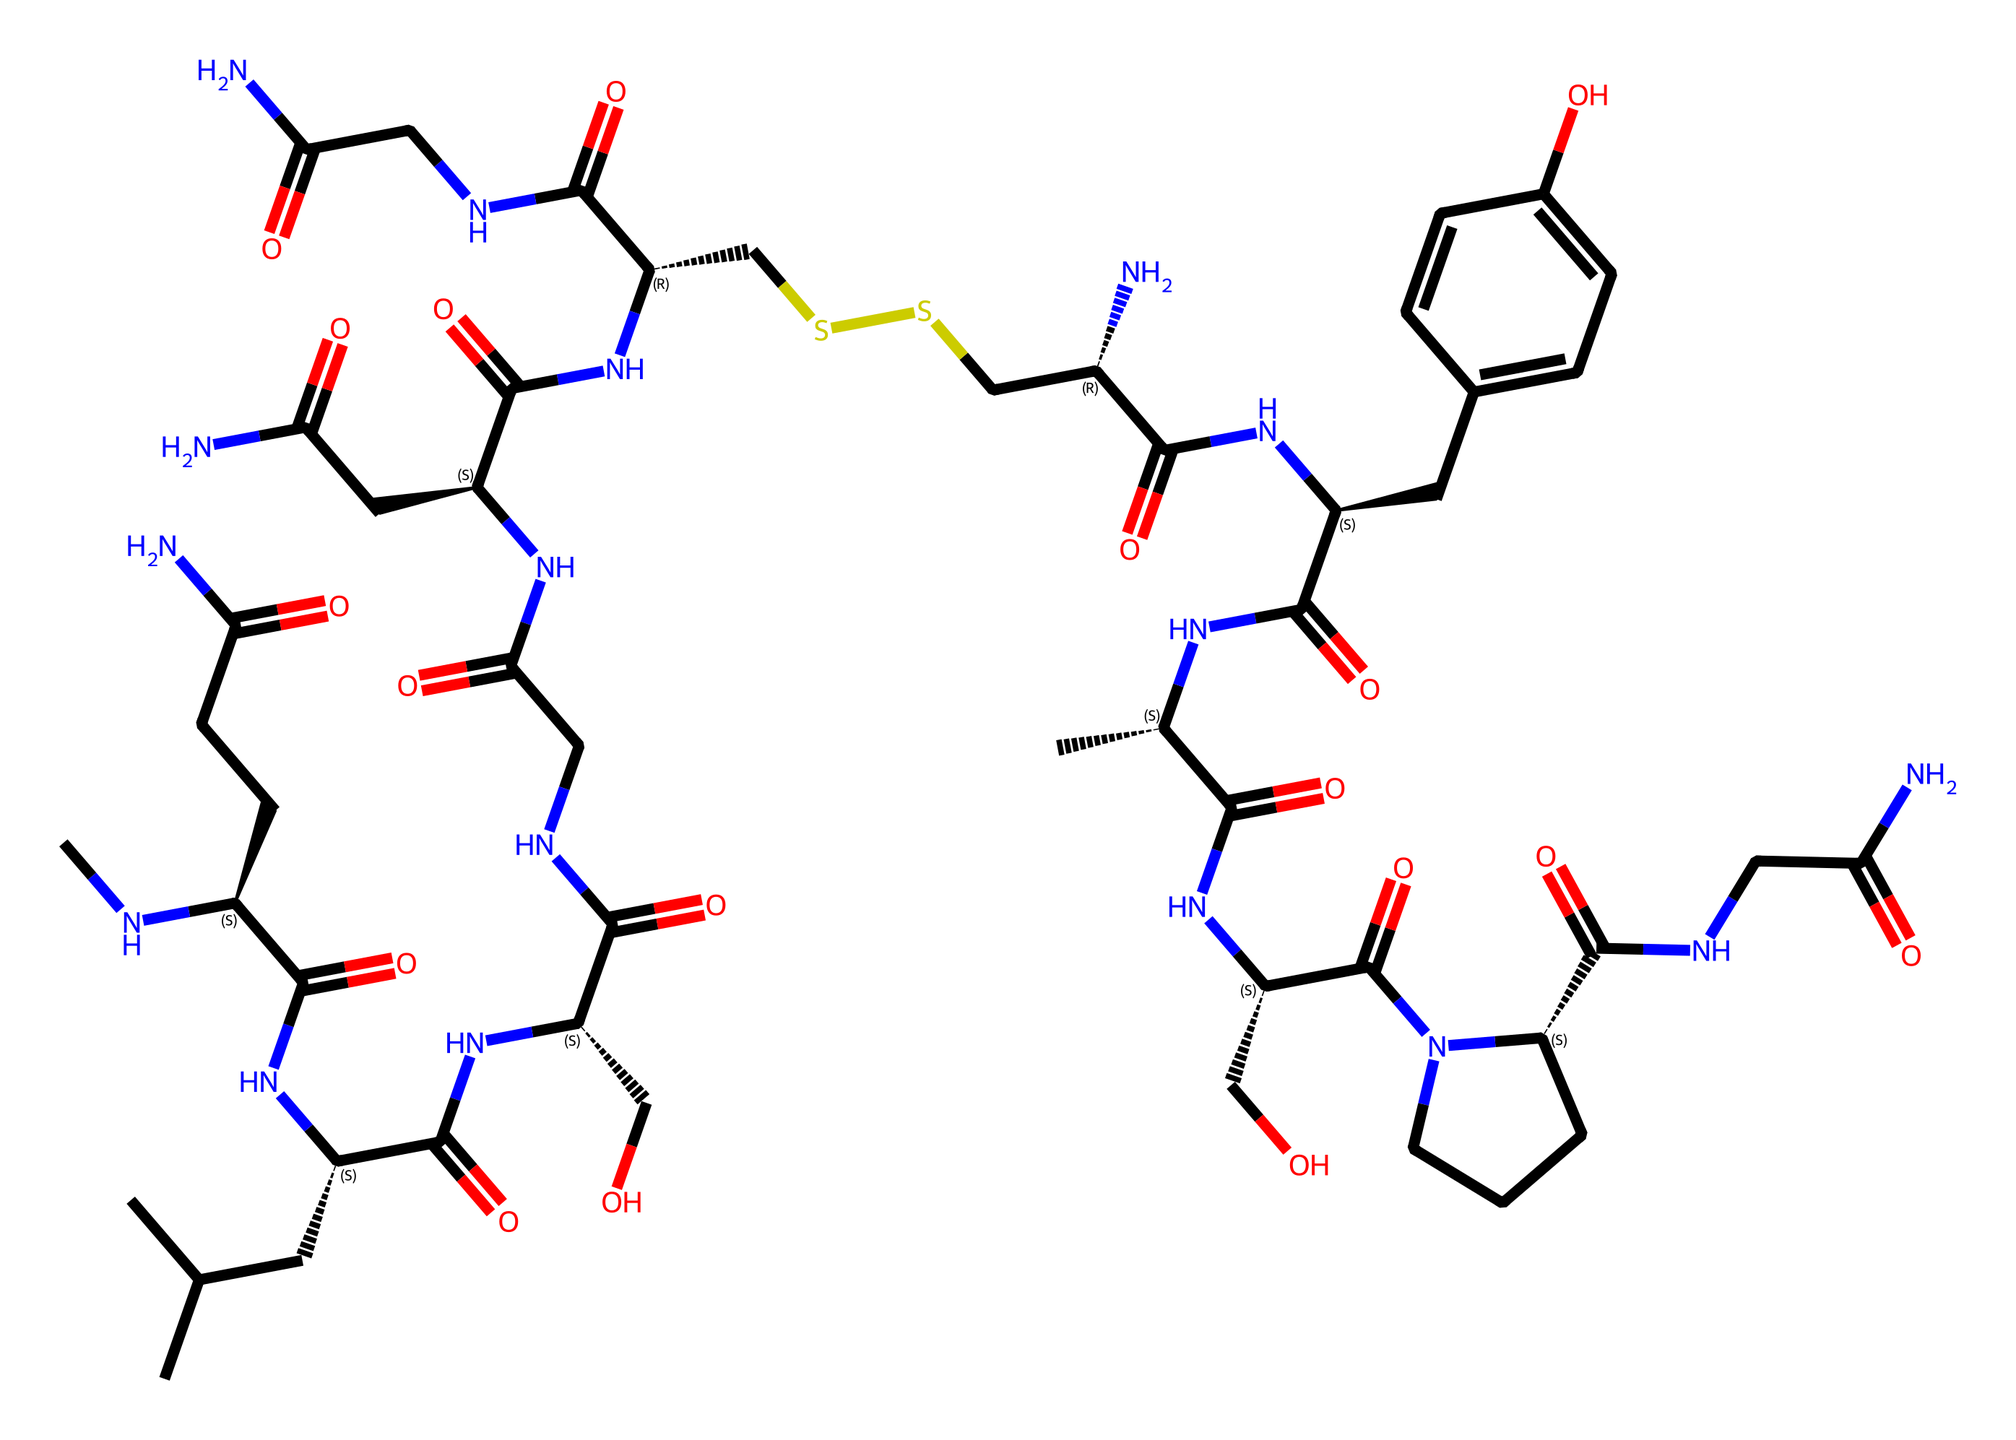What is the molecular formula for this chemical? To determine the molecular formula, count the number of each type of atom present in the SMILES representation. Identify the carbon (C), hydrogen (H), nitrogen (N), oxygen (O), and sulfur (S) atoms and sum them up to form the formula. The counts yield C43, H66, N12, O10, S2.
Answer: C43H66N12O10S2 How many nitrogen atoms are present in the structure? Review the SMILES string for nitrogen (N) atoms. By counting the occurrences, there are 12 nitrogen atoms in the chemical's structure.
Answer: 12 What type of bonding is predominant in this chemical? Looking at the SMILES representation, this compound contains multiple amide groups (indicated by the NC=O bonds), which means that covalent bonds are predominant due to the connections among carbon, nitrogen, and oxygen.
Answer: covalent Which functional groups are present in this chemical? Analyze the structure for common functional groups. The SMILES indicates the presence of amides (RCONH), hydroxyl groups (–OH), and disulfide linkages (–S–S–). Identifying these groups gives insight into the overall chemical behavior.
Answer: amides, hydroxyls, disulfide What does the presence of sulfur indicate about this chemical's properties? The presence of sulfur in the disulfide groups is crucial for protein structure and function, indicating that this chemical may play a role in protein interactions and stability due to the formation of disulfide bridges.
Answer: protein interactions How many chiral centers are in this molecule? Examine the SMILES to find the chirality centers, which are generally marked by the symbols @ or @@. Counting these gives the total number of chiral centers. There are 6 chiral centers in this molecule.
Answer: 6 